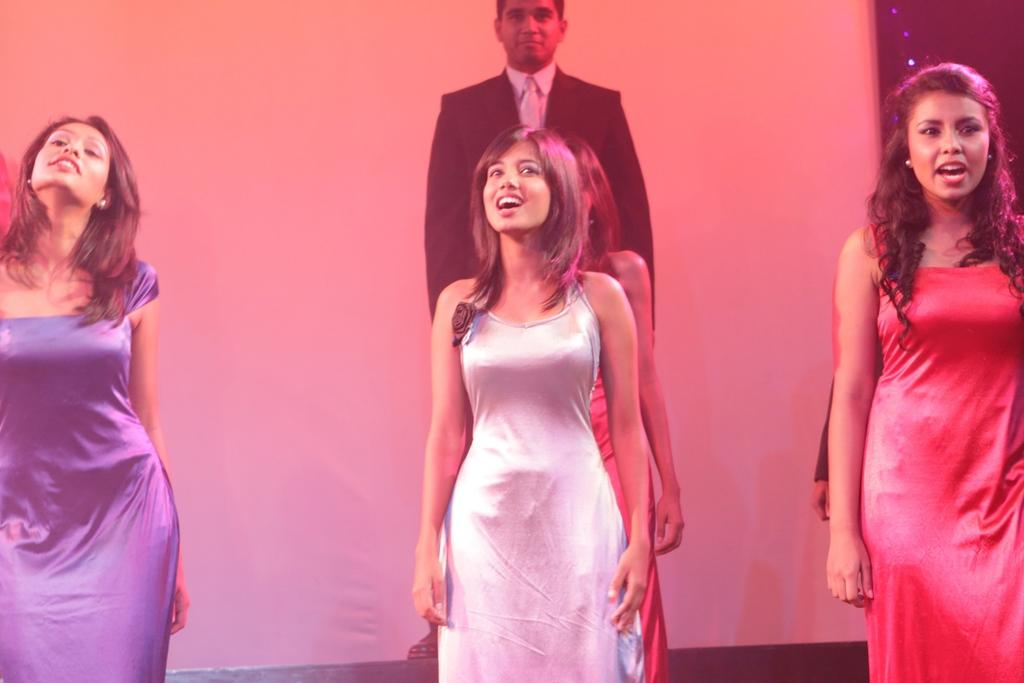What is happening in the image? There are people standing in the image. Can you describe the background of the image? There is a white curtain in the background of the image. Are there any fairies visible in the image? No fairies are visible in the image. 